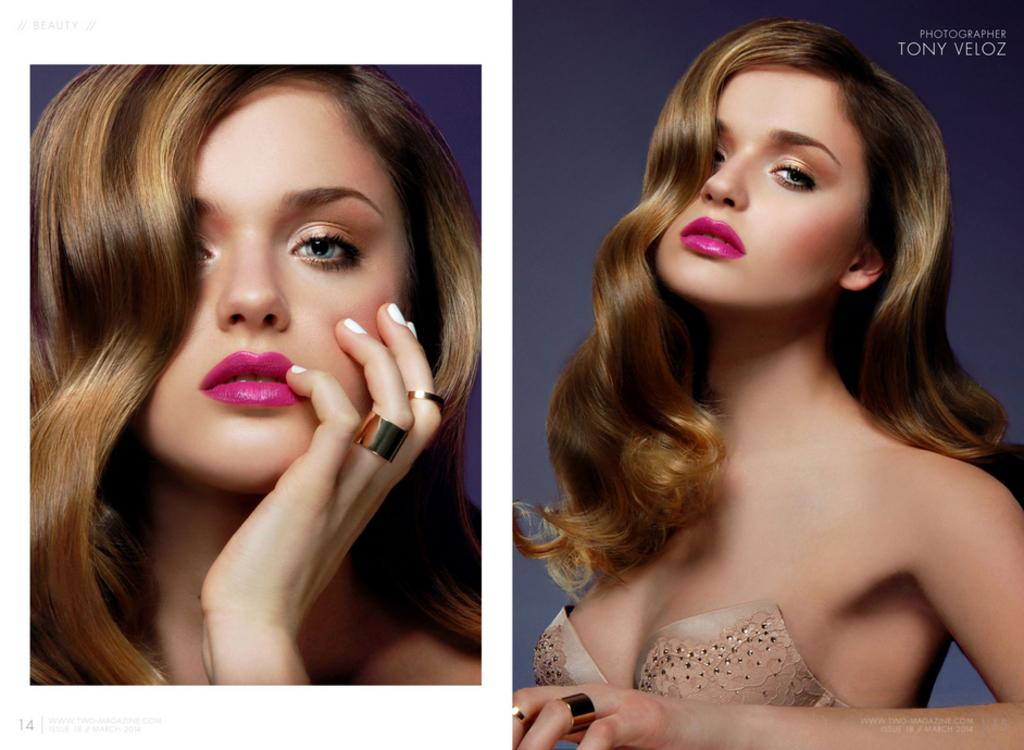What is the composition of the image? The image is a collage of two images. Can you describe the subjects in the collage? There is a woman in the collage. Where is the text located in the collage? The text is in the top right side of the collage. What type of knot is being tied by the woman in the image? There is no woman tying a knot in the image; the collage only features a woman and text. Can you hear the bell ringing in the image? There is no bell present in the image, so it cannot be heard. 